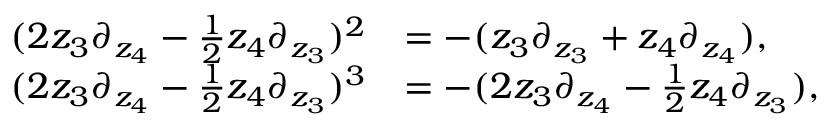<formula> <loc_0><loc_0><loc_500><loc_500>\begin{array} { r l } { ( 2 z _ { 3 } \partial _ { z _ { 4 } } - \frac { 1 } { 2 } z _ { 4 } \partial _ { z _ { 3 } } ) ^ { 2 } } & { = - ( z _ { 3 } \partial _ { z _ { 3 } } + z _ { 4 } \partial _ { z _ { 4 } } ) , } \\ { ( 2 z _ { 3 } \partial _ { z _ { 4 } } - \frac { 1 } { 2 } z _ { 4 } \partial _ { z _ { 3 } } ) ^ { 3 } } & { = - ( 2 z _ { 3 } \partial _ { z _ { 4 } } - \frac { 1 } { 2 } z _ { 4 } \partial _ { z _ { 3 } } ) , } \end{array}</formula> 